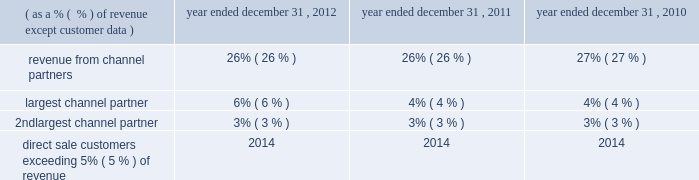Capitalized software : internally developed computer software costs and costs of product enhancements are capitalized subsequent to the determination of technological feasibility ; such capitalization continues until the product becomes available for commercial release .
Judgment is required in determining when technological feasibility of a product is established .
The company has determined that technological feasibility is reached after all high-risk development issues have been resolved through coding and testing .
Generally , the time between the establishment of technological feasibility and commercial release of software is minimal , resulting in insignificant or no capitalization of internally developed software costs .
Amortization of capitalized software costs , both for internally developed as well as for purchased software products , is computed on a product-by-product basis over the estimated economic life of the product , which is generally three years .
Amortization is the greater of the amount computed using : ( i ) the ratio of the current year 2019s gross revenue to the total current and anticipated future gross revenue for that product or ( ii ) the straight-line method over the estimated life of the product .
Amortization expense related to capitalized and acquired software costs , including the related trademarks , was $ 40.9 million , $ 33.7 million and $ 32.8 million for the years ended december 31 , 2012 , 2011 and 2010 , respectively .
The company periodically reviews the carrying value of capitalized software .
Impairments are recognized in the results of operations when the expected future undiscounted operating cash flow derived from the capitalized costs of internally developed software is less than the carrying value .
No impairment charges have been required to date .
Goodwill and other intangible assets : goodwill represents the excess of the consideration transferred over the fair value of net identifiable assets acquired .
Intangible assets consist of trademarks , customer lists , contract backlog , and acquired software and technology .
The company tests goodwill for impairment at least annually by performing a qualitative assessment of whether there is sufficient evidence that it is more likely than not that the fair value of each reporting unit exceeds its carrying amount .
The application of a qualitative assessment requires the company to assess and make judgments regarding a variety of factors which potentially impact the fair value of a reporting unit , including general economic conditions , industry and market-specific conditions , customer behavior , cost factors , the company 2019s financial performance and trends , the company 2019s strategies and business plans , capital requirements , management and personnel issues , and the company 2019s stock price , among others .
The company then considers the totality of these and other factors , placing more weight on the events and circumstances that are judged to most affect a reporting unit 2019s fair value or the carrying amount of its net assets , to reach a qualitative conclusion regarding whether it is more likely than not that the fair value of a reporting unit is less than its carrying amount .
If it is determined that it is more likely than not that the fair value of a reporting unit exceeds its carrying value , no further analysis is necessary .
If it is determined that it is more likely than not the reporting unit's carrying value exceeds its fair value , a quantitative two-step analysis is performed where the fair value of the reporting unit is estimated and the impairment loss , if any , is recorded .
The company tests indefinite-lived intangible assets for impairment at least annually by comparing the carrying value of the asset to its estimated fair value .
The company performs its annual goodwill and indefinite-lived intangible assets impairment test on january 1 of each year unless there is an indicator that would require a test during the year .
The company periodically reviews the carrying value of other intangible assets and will recognize impairments when events or circumstances indicate that such assets may be impaired .
No impairment charges have been required to date for the company's goodwill and other intangible assets .
Concentrations of credit risk : the company has a concentration of credit risk with respect to revenue and trade receivables due to the use of certain significant channel partners to market and sell the company 2019s products .
The company performs periodic credit evaluations of its customers 2019 financial condition and generally does not require collateral .
The table outlines concentrations of risk with respect to the company 2019s revenue: .
Table of contents .
What is the average amortization expense related to capitalized and acquired software costs , including the related trademarks , from 2010-2012 , in millions ? \\n? 
Computations: (((40.9 + 33.7) + 32.8) / 3)
Answer: 35.8. 